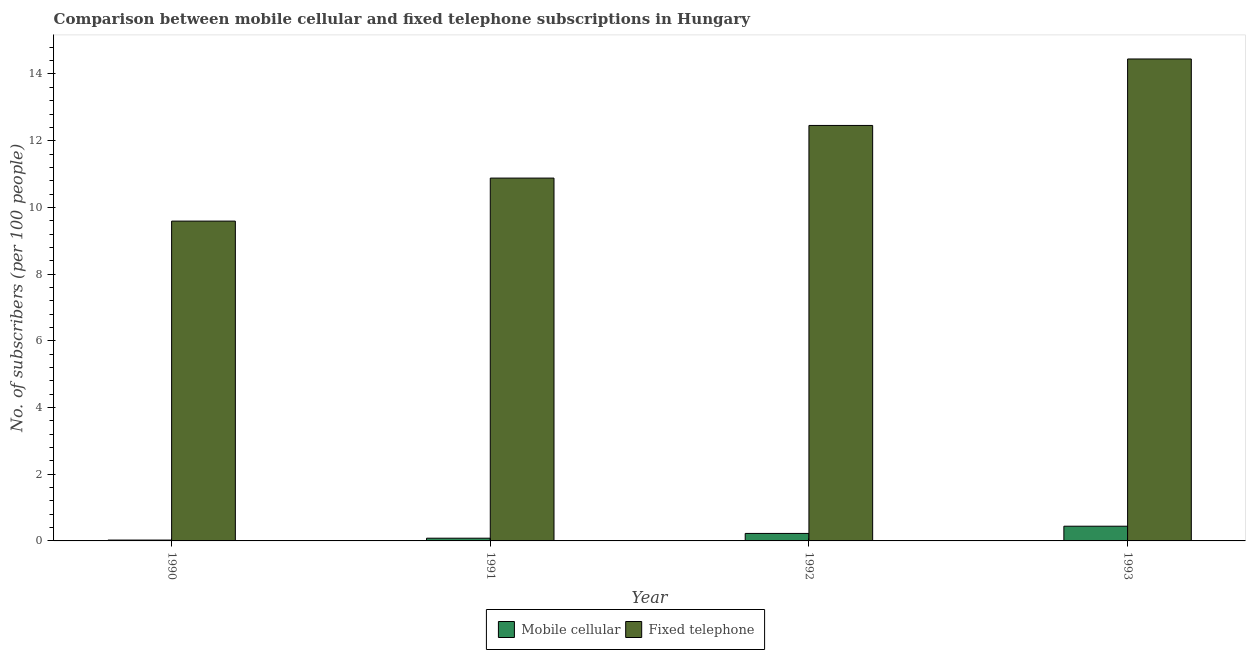Are the number of bars per tick equal to the number of legend labels?
Keep it short and to the point. Yes. How many bars are there on the 2nd tick from the right?
Give a very brief answer. 2. In how many cases, is the number of bars for a given year not equal to the number of legend labels?
Your response must be concise. 0. What is the number of mobile cellular subscribers in 1990?
Your answer should be compact. 0.03. Across all years, what is the maximum number of mobile cellular subscribers?
Ensure brevity in your answer.  0.44. Across all years, what is the minimum number of mobile cellular subscribers?
Keep it short and to the point. 0.03. In which year was the number of fixed telephone subscribers minimum?
Ensure brevity in your answer.  1990. What is the total number of fixed telephone subscribers in the graph?
Offer a terse response. 47.37. What is the difference between the number of fixed telephone subscribers in 1990 and that in 1991?
Make the answer very short. -1.29. What is the difference between the number of mobile cellular subscribers in 1990 and the number of fixed telephone subscribers in 1992?
Offer a terse response. -0.2. What is the average number of fixed telephone subscribers per year?
Your answer should be very brief. 11.84. In the year 1993, what is the difference between the number of mobile cellular subscribers and number of fixed telephone subscribers?
Make the answer very short. 0. What is the ratio of the number of fixed telephone subscribers in 1991 to that in 1993?
Provide a short and direct response. 0.75. Is the number of mobile cellular subscribers in 1990 less than that in 1993?
Offer a very short reply. Yes. What is the difference between the highest and the second highest number of mobile cellular subscribers?
Keep it short and to the point. 0.22. What is the difference between the highest and the lowest number of mobile cellular subscribers?
Offer a very short reply. 0.42. What does the 1st bar from the left in 1991 represents?
Provide a succinct answer. Mobile cellular. What does the 1st bar from the right in 1991 represents?
Provide a short and direct response. Fixed telephone. How many years are there in the graph?
Provide a short and direct response. 4. What is the difference between two consecutive major ticks on the Y-axis?
Offer a very short reply. 2. Are the values on the major ticks of Y-axis written in scientific E-notation?
Offer a very short reply. No. Does the graph contain any zero values?
Provide a short and direct response. No. Does the graph contain grids?
Offer a very short reply. No. How are the legend labels stacked?
Offer a terse response. Horizontal. What is the title of the graph?
Provide a short and direct response. Comparison between mobile cellular and fixed telephone subscriptions in Hungary. Does "Non-resident workers" appear as one of the legend labels in the graph?
Keep it short and to the point. No. What is the label or title of the Y-axis?
Your answer should be very brief. No. of subscribers (per 100 people). What is the No. of subscribers (per 100 people) of Mobile cellular in 1990?
Make the answer very short. 0.03. What is the No. of subscribers (per 100 people) in Fixed telephone in 1990?
Your answer should be compact. 9.59. What is the No. of subscribers (per 100 people) of Mobile cellular in 1991?
Keep it short and to the point. 0.08. What is the No. of subscribers (per 100 people) of Fixed telephone in 1991?
Keep it short and to the point. 10.88. What is the No. of subscribers (per 100 people) in Mobile cellular in 1992?
Offer a terse response. 0.22. What is the No. of subscribers (per 100 people) in Fixed telephone in 1992?
Your response must be concise. 12.46. What is the No. of subscribers (per 100 people) of Mobile cellular in 1993?
Give a very brief answer. 0.44. What is the No. of subscribers (per 100 people) of Fixed telephone in 1993?
Provide a succinct answer. 14.45. Across all years, what is the maximum No. of subscribers (per 100 people) of Mobile cellular?
Keep it short and to the point. 0.44. Across all years, what is the maximum No. of subscribers (per 100 people) in Fixed telephone?
Offer a very short reply. 14.45. Across all years, what is the minimum No. of subscribers (per 100 people) of Mobile cellular?
Offer a terse response. 0.03. Across all years, what is the minimum No. of subscribers (per 100 people) of Fixed telephone?
Provide a succinct answer. 9.59. What is the total No. of subscribers (per 100 people) in Mobile cellular in the graph?
Keep it short and to the point. 0.77. What is the total No. of subscribers (per 100 people) of Fixed telephone in the graph?
Provide a succinct answer. 47.37. What is the difference between the No. of subscribers (per 100 people) of Mobile cellular in 1990 and that in 1991?
Provide a short and direct response. -0.06. What is the difference between the No. of subscribers (per 100 people) in Fixed telephone in 1990 and that in 1991?
Make the answer very short. -1.29. What is the difference between the No. of subscribers (per 100 people) of Mobile cellular in 1990 and that in 1992?
Your answer should be very brief. -0.2. What is the difference between the No. of subscribers (per 100 people) in Fixed telephone in 1990 and that in 1992?
Provide a succinct answer. -2.87. What is the difference between the No. of subscribers (per 100 people) in Mobile cellular in 1990 and that in 1993?
Provide a short and direct response. -0.42. What is the difference between the No. of subscribers (per 100 people) of Fixed telephone in 1990 and that in 1993?
Provide a short and direct response. -4.86. What is the difference between the No. of subscribers (per 100 people) in Mobile cellular in 1991 and that in 1992?
Provide a short and direct response. -0.14. What is the difference between the No. of subscribers (per 100 people) in Fixed telephone in 1991 and that in 1992?
Ensure brevity in your answer.  -1.58. What is the difference between the No. of subscribers (per 100 people) of Mobile cellular in 1991 and that in 1993?
Your answer should be compact. -0.36. What is the difference between the No. of subscribers (per 100 people) of Fixed telephone in 1991 and that in 1993?
Provide a succinct answer. -3.57. What is the difference between the No. of subscribers (per 100 people) in Mobile cellular in 1992 and that in 1993?
Keep it short and to the point. -0.22. What is the difference between the No. of subscribers (per 100 people) of Fixed telephone in 1992 and that in 1993?
Give a very brief answer. -1.99. What is the difference between the No. of subscribers (per 100 people) of Mobile cellular in 1990 and the No. of subscribers (per 100 people) of Fixed telephone in 1991?
Make the answer very short. -10.85. What is the difference between the No. of subscribers (per 100 people) in Mobile cellular in 1990 and the No. of subscribers (per 100 people) in Fixed telephone in 1992?
Your response must be concise. -12.43. What is the difference between the No. of subscribers (per 100 people) of Mobile cellular in 1990 and the No. of subscribers (per 100 people) of Fixed telephone in 1993?
Give a very brief answer. -14.42. What is the difference between the No. of subscribers (per 100 people) of Mobile cellular in 1991 and the No. of subscribers (per 100 people) of Fixed telephone in 1992?
Your answer should be compact. -12.38. What is the difference between the No. of subscribers (per 100 people) of Mobile cellular in 1991 and the No. of subscribers (per 100 people) of Fixed telephone in 1993?
Provide a succinct answer. -14.37. What is the difference between the No. of subscribers (per 100 people) in Mobile cellular in 1992 and the No. of subscribers (per 100 people) in Fixed telephone in 1993?
Offer a very short reply. -14.23. What is the average No. of subscribers (per 100 people) in Mobile cellular per year?
Your response must be concise. 0.19. What is the average No. of subscribers (per 100 people) of Fixed telephone per year?
Provide a short and direct response. 11.84. In the year 1990, what is the difference between the No. of subscribers (per 100 people) in Mobile cellular and No. of subscribers (per 100 people) in Fixed telephone?
Offer a very short reply. -9.56. In the year 1991, what is the difference between the No. of subscribers (per 100 people) of Mobile cellular and No. of subscribers (per 100 people) of Fixed telephone?
Give a very brief answer. -10.8. In the year 1992, what is the difference between the No. of subscribers (per 100 people) in Mobile cellular and No. of subscribers (per 100 people) in Fixed telephone?
Your answer should be very brief. -12.23. In the year 1993, what is the difference between the No. of subscribers (per 100 people) in Mobile cellular and No. of subscribers (per 100 people) in Fixed telephone?
Offer a very short reply. -14.01. What is the ratio of the No. of subscribers (per 100 people) in Mobile cellular in 1990 to that in 1991?
Give a very brief answer. 0.31. What is the ratio of the No. of subscribers (per 100 people) of Fixed telephone in 1990 to that in 1991?
Your answer should be very brief. 0.88. What is the ratio of the No. of subscribers (per 100 people) in Mobile cellular in 1990 to that in 1992?
Ensure brevity in your answer.  0.11. What is the ratio of the No. of subscribers (per 100 people) of Fixed telephone in 1990 to that in 1992?
Your answer should be compact. 0.77. What is the ratio of the No. of subscribers (per 100 people) in Mobile cellular in 1990 to that in 1993?
Give a very brief answer. 0.06. What is the ratio of the No. of subscribers (per 100 people) of Fixed telephone in 1990 to that in 1993?
Offer a terse response. 0.66. What is the ratio of the No. of subscribers (per 100 people) in Mobile cellular in 1991 to that in 1992?
Offer a terse response. 0.36. What is the ratio of the No. of subscribers (per 100 people) of Fixed telephone in 1991 to that in 1992?
Give a very brief answer. 0.87. What is the ratio of the No. of subscribers (per 100 people) of Mobile cellular in 1991 to that in 1993?
Offer a very short reply. 0.19. What is the ratio of the No. of subscribers (per 100 people) in Fixed telephone in 1991 to that in 1993?
Provide a succinct answer. 0.75. What is the ratio of the No. of subscribers (per 100 people) in Mobile cellular in 1992 to that in 1993?
Provide a short and direct response. 0.51. What is the ratio of the No. of subscribers (per 100 people) of Fixed telephone in 1992 to that in 1993?
Your response must be concise. 0.86. What is the difference between the highest and the second highest No. of subscribers (per 100 people) of Mobile cellular?
Offer a very short reply. 0.22. What is the difference between the highest and the second highest No. of subscribers (per 100 people) of Fixed telephone?
Provide a succinct answer. 1.99. What is the difference between the highest and the lowest No. of subscribers (per 100 people) in Mobile cellular?
Offer a very short reply. 0.42. What is the difference between the highest and the lowest No. of subscribers (per 100 people) in Fixed telephone?
Your answer should be compact. 4.86. 